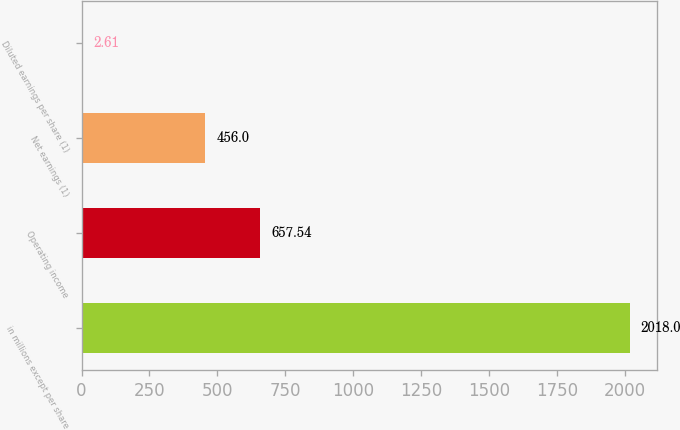Convert chart. <chart><loc_0><loc_0><loc_500><loc_500><bar_chart><fcel>in millions except per share<fcel>Operating income<fcel>Net earnings (1)<fcel>Diluted earnings per share (1)<nl><fcel>2018<fcel>657.54<fcel>456<fcel>2.61<nl></chart> 